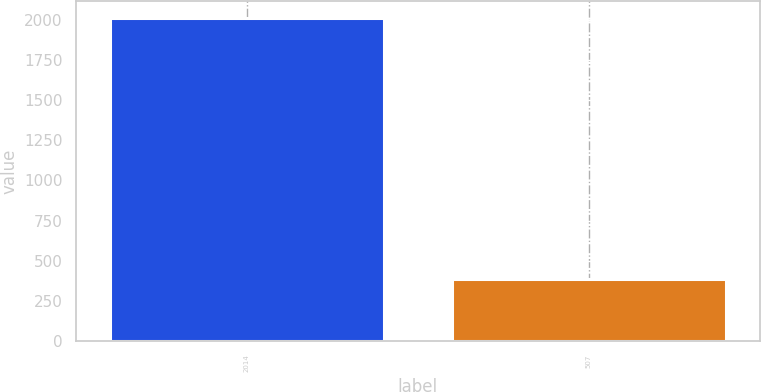<chart> <loc_0><loc_0><loc_500><loc_500><bar_chart><fcel>2014<fcel>507<nl><fcel>2012<fcel>386<nl></chart> 